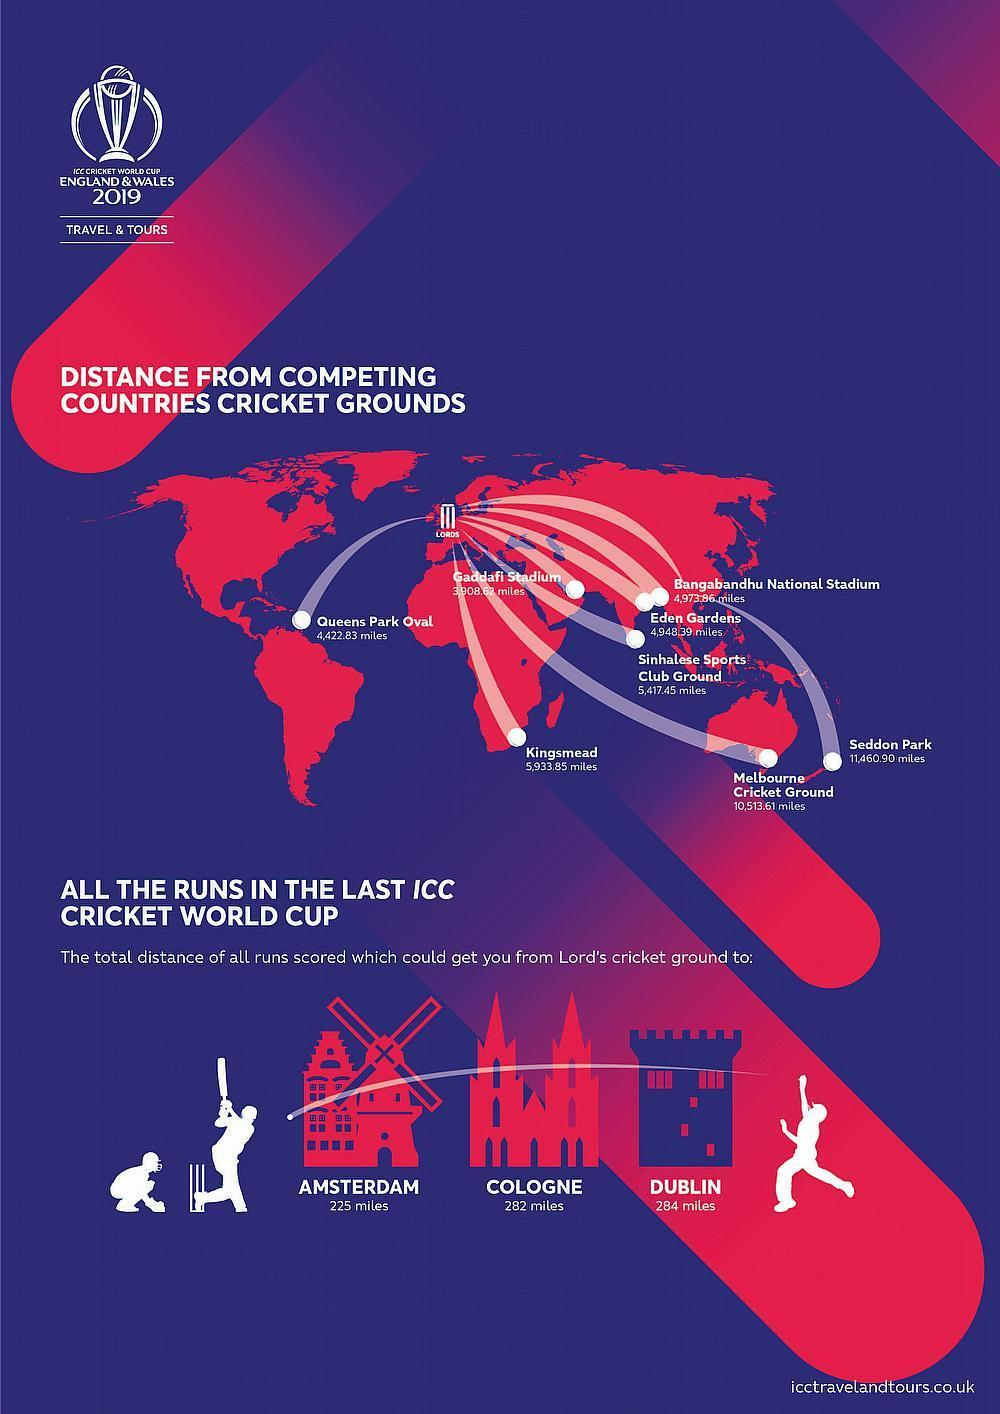what is the distance between Lords and Melbourne Cricket Ground
Answer the question with a short phrase. 10,513.61 miles which stadium is in India Eden Gardens which stadium is in Africa Kingsmead Which stadium is in the American continent Queens Park Oval which stadium is in Sri Lanka Sinhalese Sports Club Ground What is the distance between Lords and Kingsmead 5,933.85 miles 